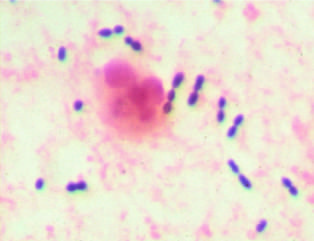what are evident?
Answer the question using a single word or phrase. Elongated cocci in pairs and short chains (streptococcus pneumoniae) and a neutrophil 